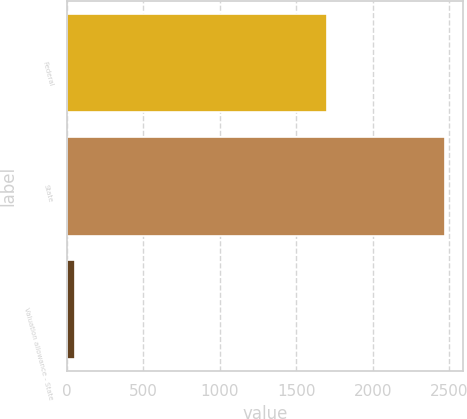Convert chart. <chart><loc_0><loc_0><loc_500><loc_500><bar_chart><fcel>Federal<fcel>State<fcel>Valuation allowance - State<nl><fcel>1698<fcel>2468<fcel>54<nl></chart> 